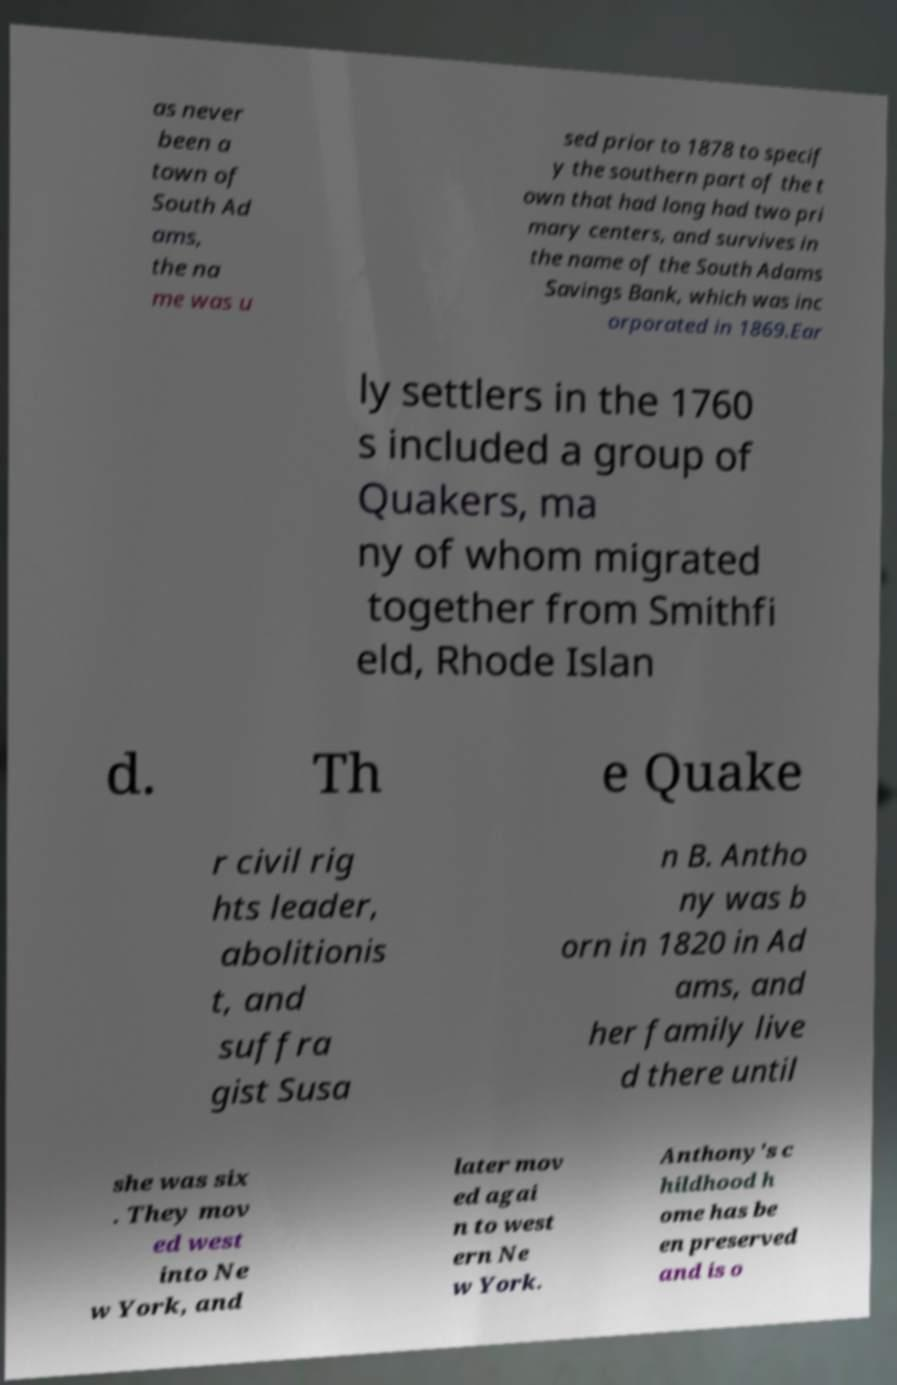There's text embedded in this image that I need extracted. Can you transcribe it verbatim? as never been a town of South Ad ams, the na me was u sed prior to 1878 to specif y the southern part of the t own that had long had two pri mary centers, and survives in the name of the South Adams Savings Bank, which was inc orporated in 1869.Ear ly settlers in the 1760 s included a group of Quakers, ma ny of whom migrated together from Smithfi eld, Rhode Islan d. Th e Quake r civil rig hts leader, abolitionis t, and suffra gist Susa n B. Antho ny was b orn in 1820 in Ad ams, and her family live d there until she was six . They mov ed west into Ne w York, and later mov ed agai n to west ern Ne w York. Anthony's c hildhood h ome has be en preserved and is o 